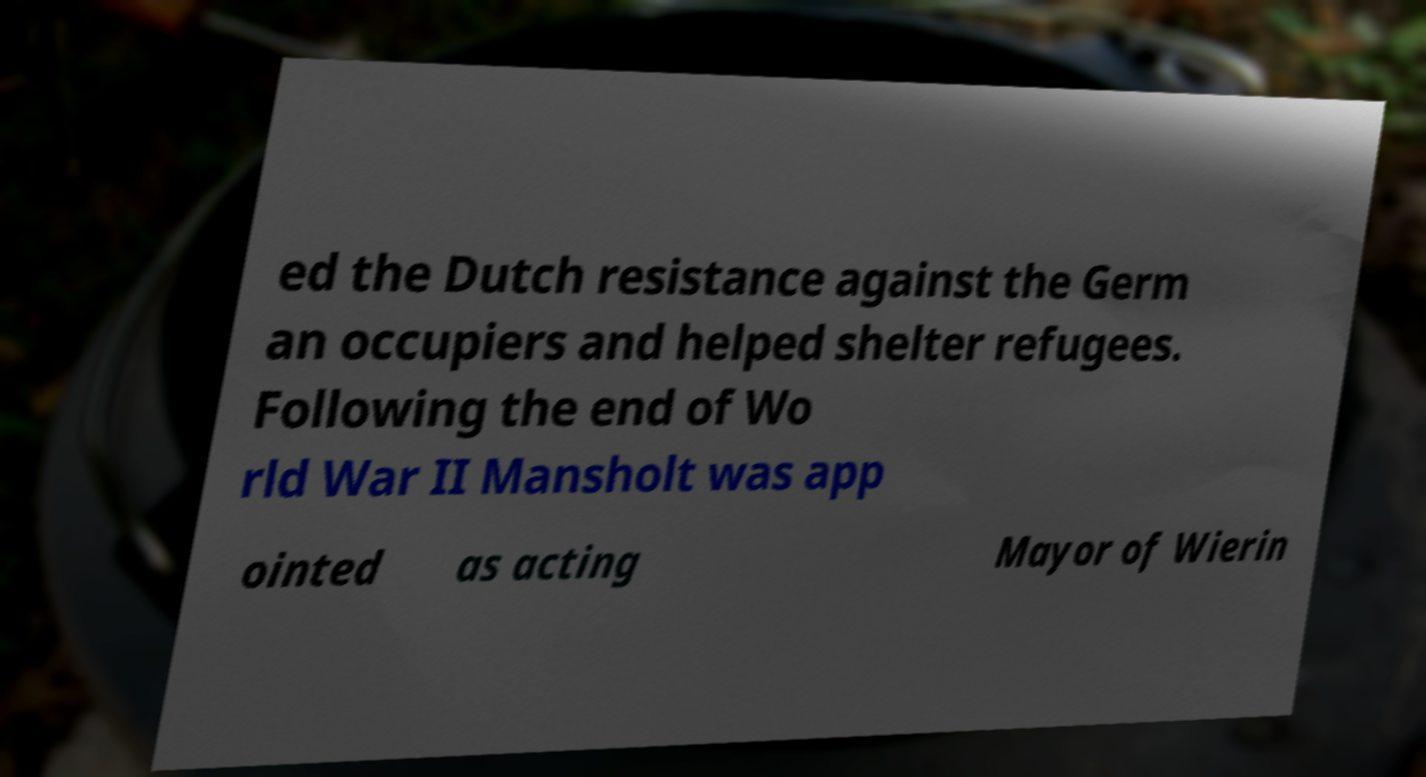There's text embedded in this image that I need extracted. Can you transcribe it verbatim? ed the Dutch resistance against the Germ an occupiers and helped shelter refugees. Following the end of Wo rld War II Mansholt was app ointed as acting Mayor of Wierin 